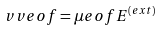Convert formula to latex. <formula><loc_0><loc_0><loc_500><loc_500>\ v v e o f = \mu e o f { E } ^ { ( e x t ) }</formula> 